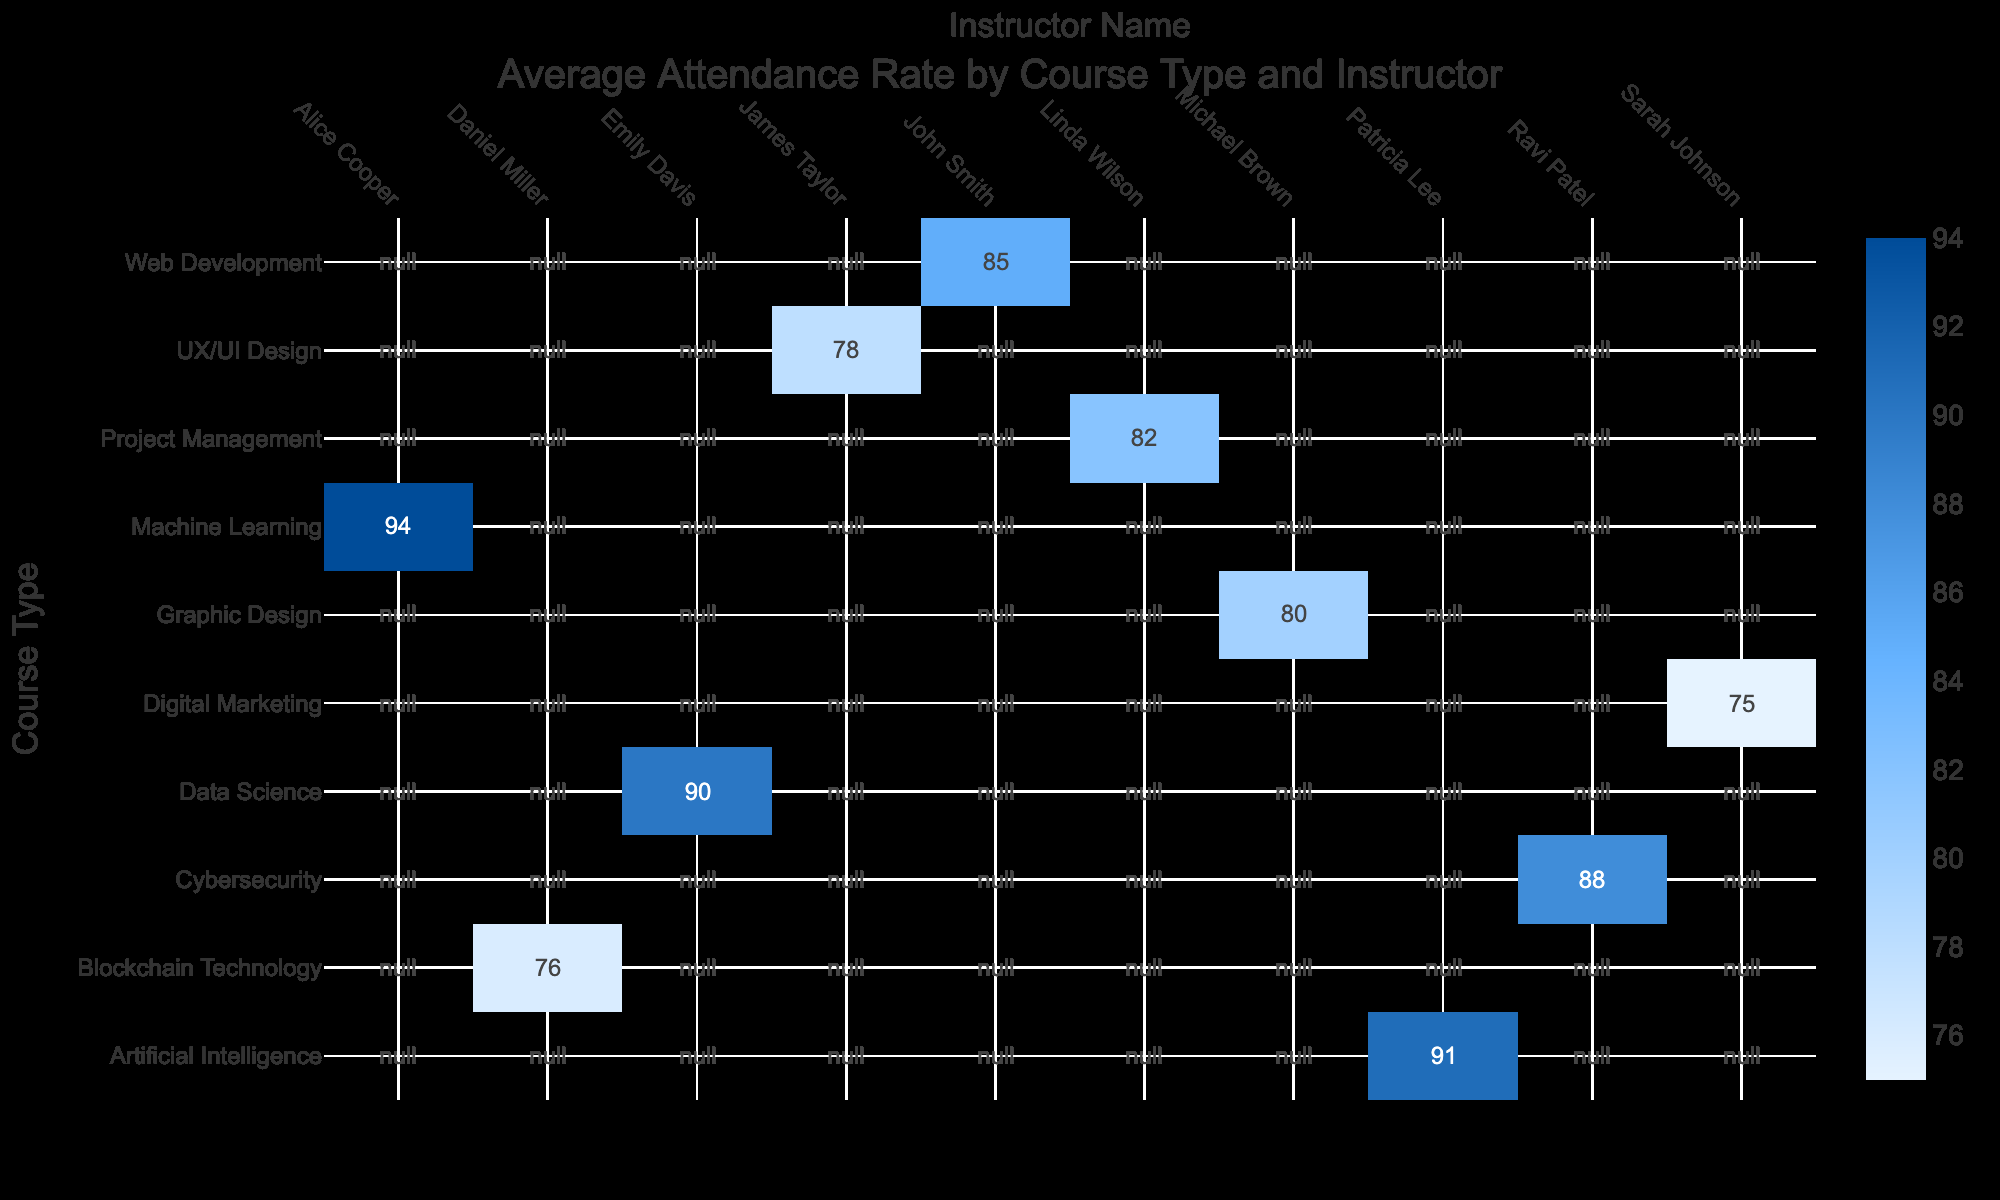What is the attendance rate for the Data Science course taught by Emily Davis? The table shows that the attendance rate for the Data Science course is listed under the row for Data Science and the column for Emily Davis, which is 90.
Answer: 90 Which instructor received the highest attendance rate across all courses? By looking through the attendance rates for each instructor, Alice Cooper is associated with the Machine Learning course, which has the highest attendance rate of 94.
Answer: 94 Is the attendance rate for Cybersecurity higher than that for Digital Marketing? The attendance rate for Cybersecurity is 88 and for Digital Marketing is 75. Since 88 is greater than 75, the attendance rate for Cybersecurity is indeed higher.
Answer: Yes What is the average attendance rate for the courses taught by instructors who have a feedback score of 4.5 or higher? The instructors with a feedback score of 4.5 or higher are John Smith (85), Emily Davis (90), Ravi Patel (88), Linda Wilson (82), Alice Cooper (94), and Patricia Lee (91). Summing these attendance rates gives 85 + 90 + 88 + 82 + 94 + 91 = 530. There are 6 values, so the average is 530 / 6 = 88.3.
Answer: 88.3 Which course type has the lowest attendance rate, and what is that rate? From the attendance rates listed, Digital Marketing has the lowest attendance rate of 75 when compared to other course types.
Answer: 75 Do any of the instructors have an attendance rate of 80 or above? Looking through the attendance rates listed, we find that John Smith (85), Emily Davis (90), Ravi Patel (88), Alice Cooper (94), and Patricia Lee (91) all have attendance rates of 80 or above.
Answer: Yes What is the difference in attendance rate between the Graphic Design course and the Machine Learning course? The attendance rate for Graphic Design is 80, while the rate for Machine Learning is 94. The difference is 94 - 80 = 14.
Answer: 14 How many instructors have feedback scores lower than 4.3? Reviewing the feedback scores, we see that the only instructor with a score lower than 4.3 is James Taylor, who has a score of 4.1. Thus, there is 1 instructor with a score below 4.3.
Answer: 1 What is the combined attendance rate of the courses taught by instructors with a feedback score of 4.2? The instructors with a feedback score of 4.2 are Sarah Johnson (75) and Daniel Miller (76). Adding these provides 75 + 76 = 151.
Answer: 151 